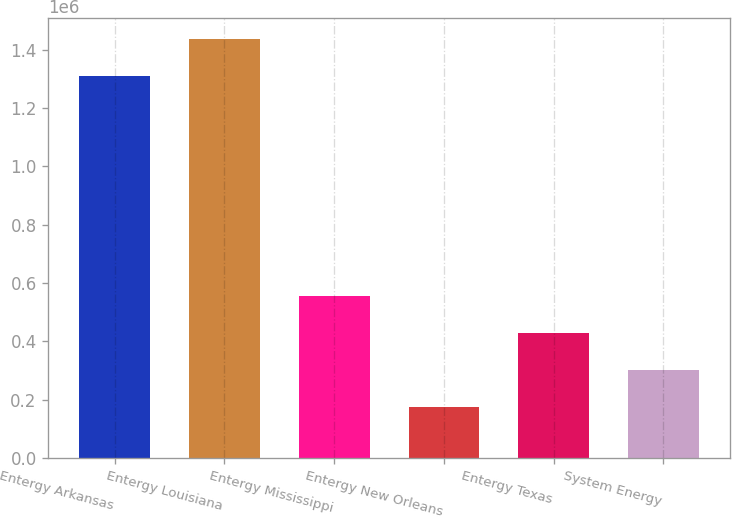Convert chart to OTSL. <chart><loc_0><loc_0><loc_500><loc_500><bar_chart><fcel>Entergy Arkansas<fcel>Entergy Louisiana<fcel>Entergy Mississippi<fcel>Entergy New Orleans<fcel>Entergy Texas<fcel>System Energy<nl><fcel>1.3099e+06<fcel>1.43654e+06<fcel>554645<fcel>176692<fcel>428661<fcel>302676<nl></chart> 